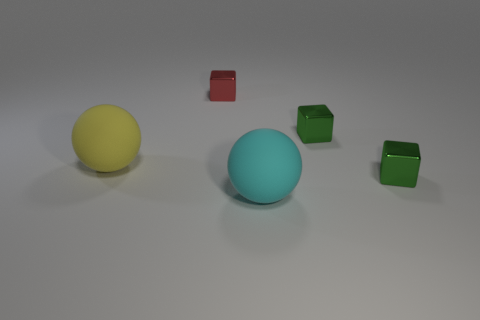What is the material of the red object?
Your response must be concise. Metal. What number of other things are the same size as the yellow ball?
Make the answer very short. 1. There is a red thing right of the large yellow matte object; what is its size?
Keep it short and to the point. Small. The big cyan sphere that is in front of the red metal block left of the big rubber thing that is right of the yellow sphere is made of what material?
Give a very brief answer. Rubber. Is the big yellow object the same shape as the tiny red metal thing?
Provide a short and direct response. No. How many matte things are either brown spheres or small green objects?
Give a very brief answer. 0. What number of metallic blocks are there?
Your answer should be compact. 3. The thing that is the same size as the cyan rubber ball is what color?
Give a very brief answer. Yellow. Do the yellow rubber ball and the red thing have the same size?
Ensure brevity in your answer.  No. Does the yellow object have the same size as the green metal object behind the large yellow matte sphere?
Give a very brief answer. No. 